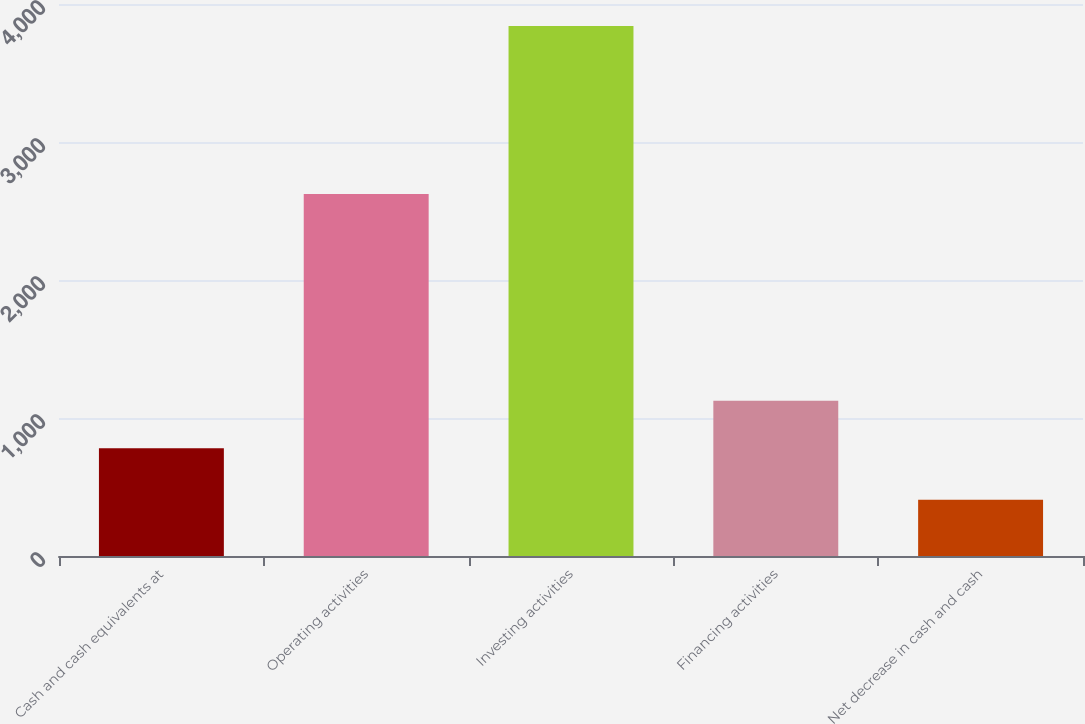Convert chart. <chart><loc_0><loc_0><loc_500><loc_500><bar_chart><fcel>Cash and cash equivalents at<fcel>Operating activities<fcel>Investing activities<fcel>Financing activities<fcel>Net decrease in cash and cash<nl><fcel>781<fcel>2624<fcel>3841<fcel>1124.4<fcel>407<nl></chart> 